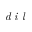<formula> <loc_0><loc_0><loc_500><loc_500>d i l</formula> 